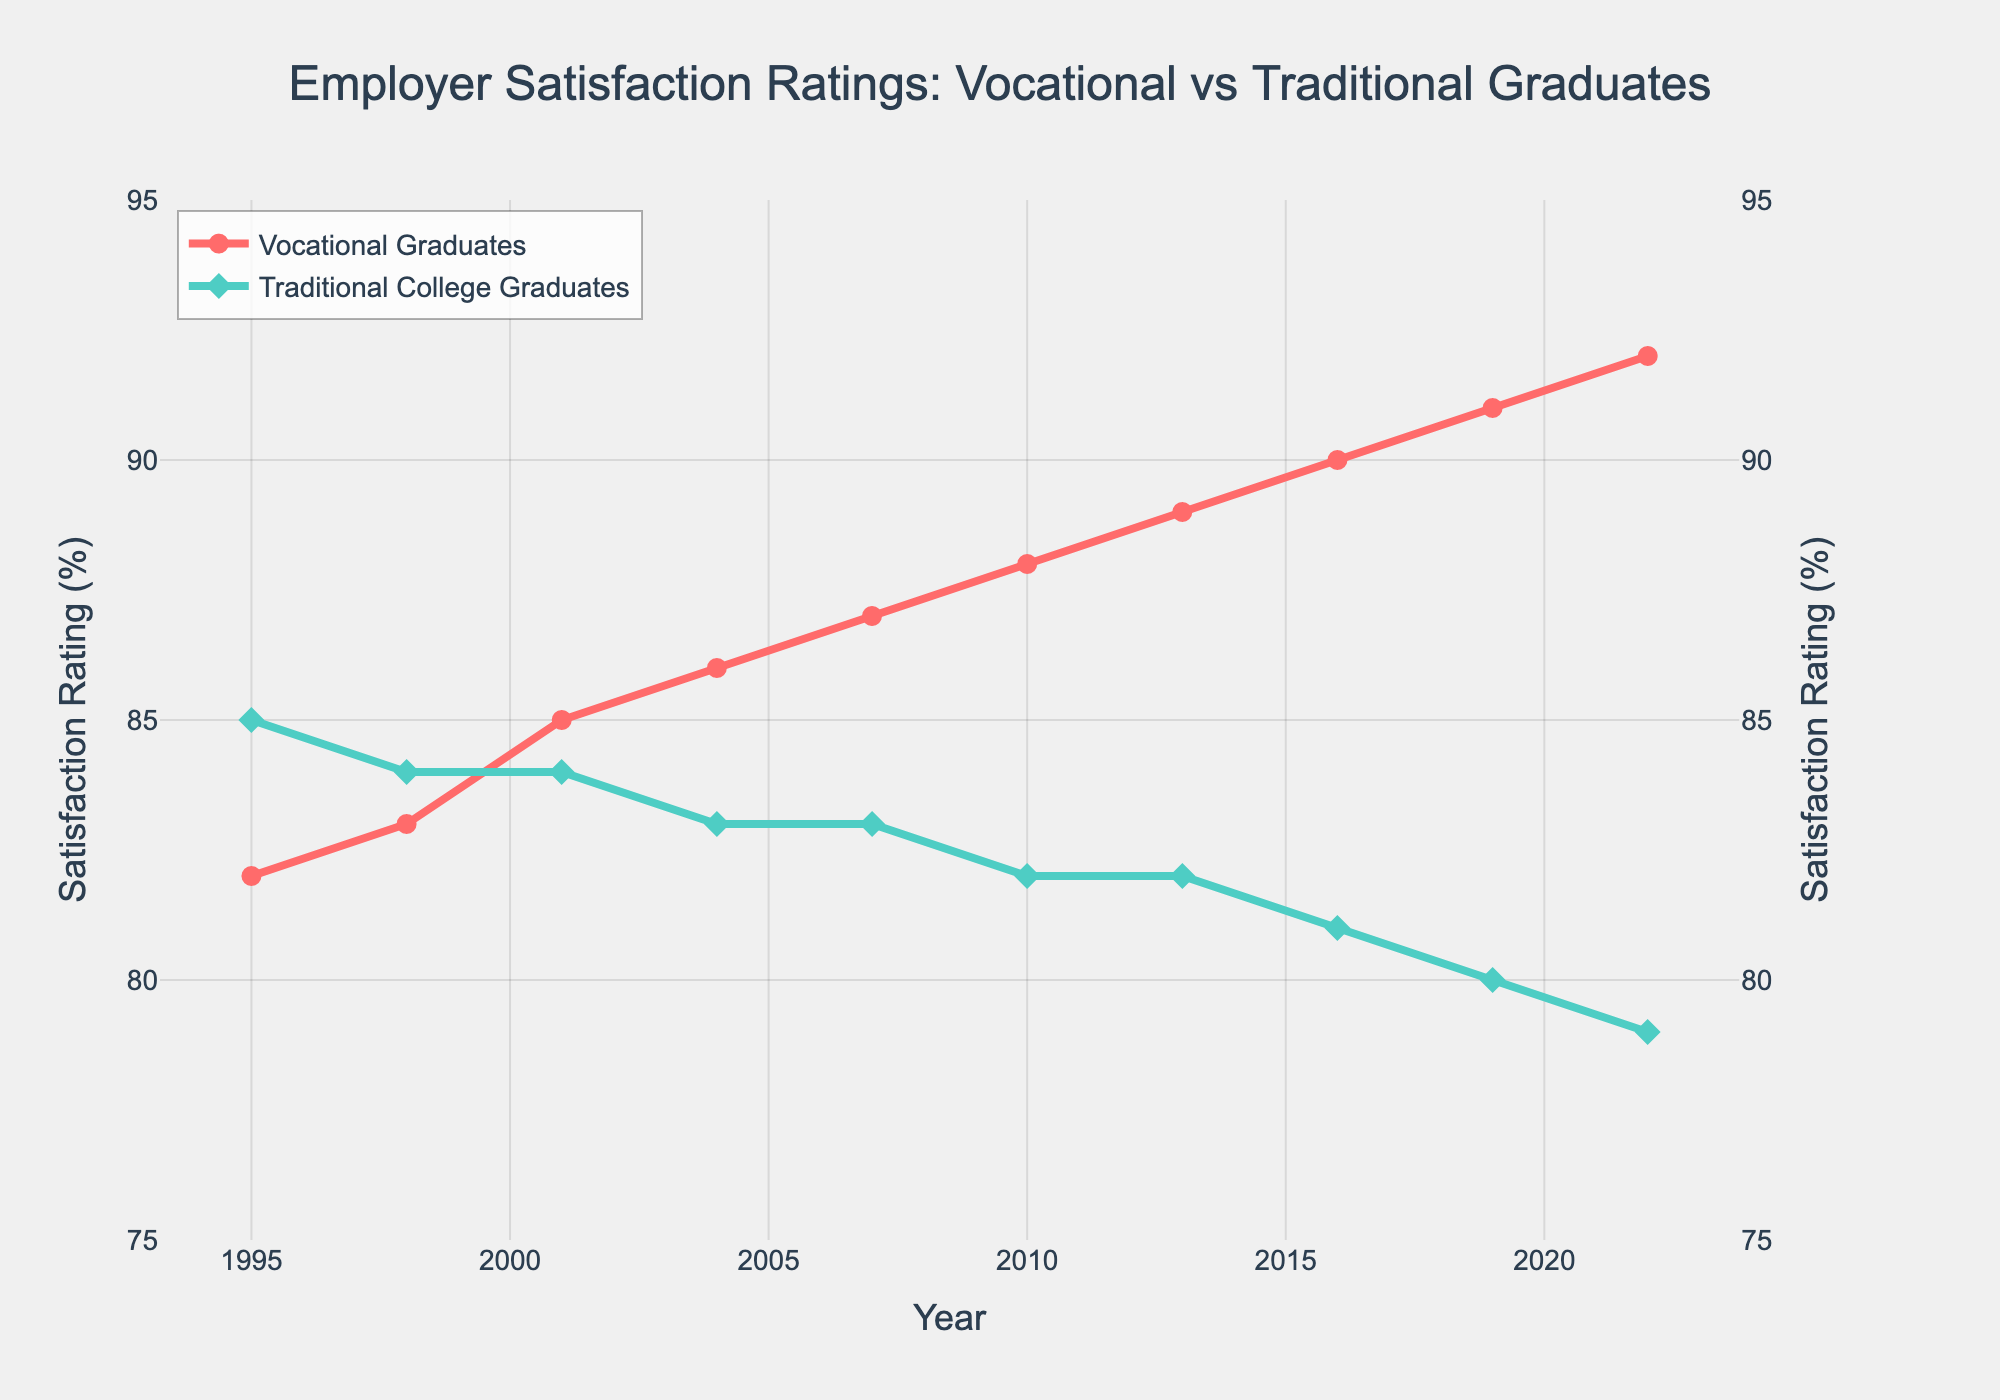What is the overall trend in employer satisfaction ratings for vocational graduates from 1995 to 2022? Employer satisfaction ratings for vocational graduates show a consistent upward trend from 82% in 1995 to 92% in 2022.
Answer: Upward trend Which year had the highest employer satisfaction rating for traditional college graduates and what was the rating? The highest employer satisfaction rating for traditional college graduates was in 1995, at 85%.
Answer: 1995, 85% By how much did the satisfaction rating for vocational graduates increase from 1995 to 2022? The satisfaction rating for vocational graduates increased from 82% in 1995 to 92% in 2022. The difference is 92% - 82% = 10%.
Answer: 10% When did vocational graduates surpass traditional college graduates in employer satisfaction ratings for the first time? Vocational graduates first surpassed traditional college graduates in 2001 when their rating was 85% compared to 84% for traditional college graduates.
Answer: 2001 Between 2007 and 2016, what was the range of employer satisfaction ratings for vocational graduates? The satisfaction ratings for vocational graduates ranged from 87% in 2007 to 90% in 2016.
Answer: 87%-90% How did the satisfaction rating for traditional college graduates change from 2010 to 2022? The satisfaction rating for traditional college graduates declined from 82% in 2010 to 79% in 2022.
Answer: Decline Compare the employer satisfaction ratings for vocational graduates and traditional college graduates in 2016. In 2016, vocational graduates had a satisfaction rating of 90%, while traditional college graduates had 81%. The vocational rating was 9% higher.
Answer: Vocational 90%, Traditional 81%, 9% higher Which year showed the largest gap between vocational graduates and traditional college graduates in terms of employer satisfaction, and what was the gap? The largest gap was in 2022, with vocational graduates at 92% and traditional college graduates at 79%. The gap was 13%.
Answer: 2022, 13% What visual feature indicates which line represents vocational graduates on the plot? The line representing vocational graduates is red in color with circular markers.
Answer: Red with circular markers What has been the average employer satisfaction rating for traditional college graduates from 1995 to 2022? The average rating is calculated by summing the ratings (85 + 84 + 84 + 83 + 83 + 82 + 82 + 81 + 80 + 79) and dividing by the number of years (10). The total is 823, so the average is 823/10 = 82.3%.
Answer: 82.3% 